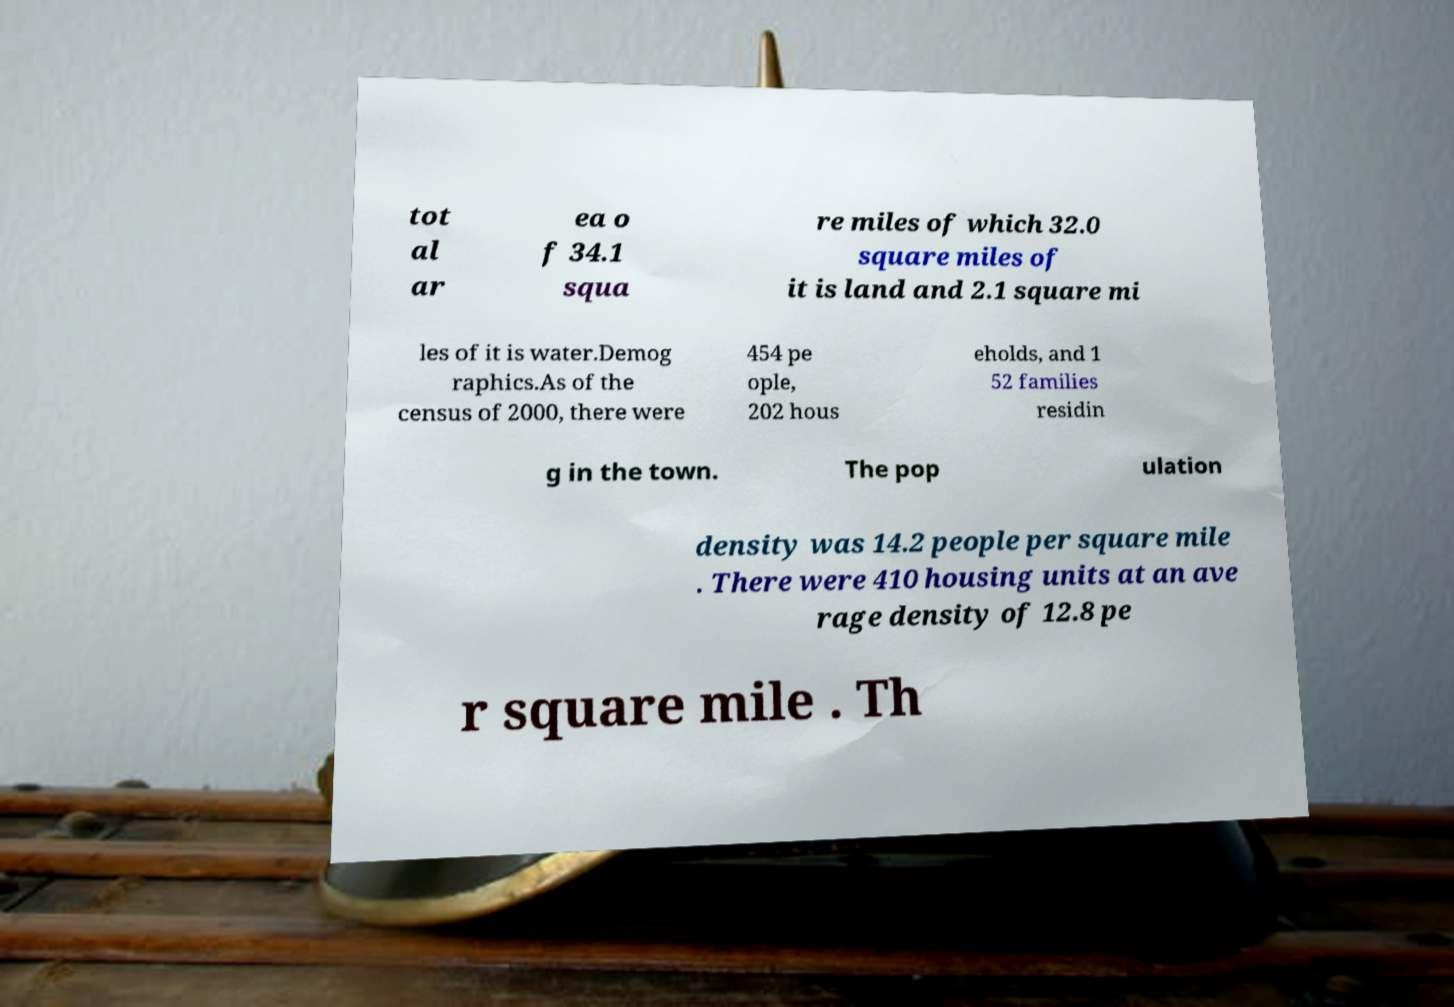Can you accurately transcribe the text from the provided image for me? tot al ar ea o f 34.1 squa re miles of which 32.0 square miles of it is land and 2.1 square mi les of it is water.Demog raphics.As of the census of 2000, there were 454 pe ople, 202 hous eholds, and 1 52 families residin g in the town. The pop ulation density was 14.2 people per square mile . There were 410 housing units at an ave rage density of 12.8 pe r square mile . Th 